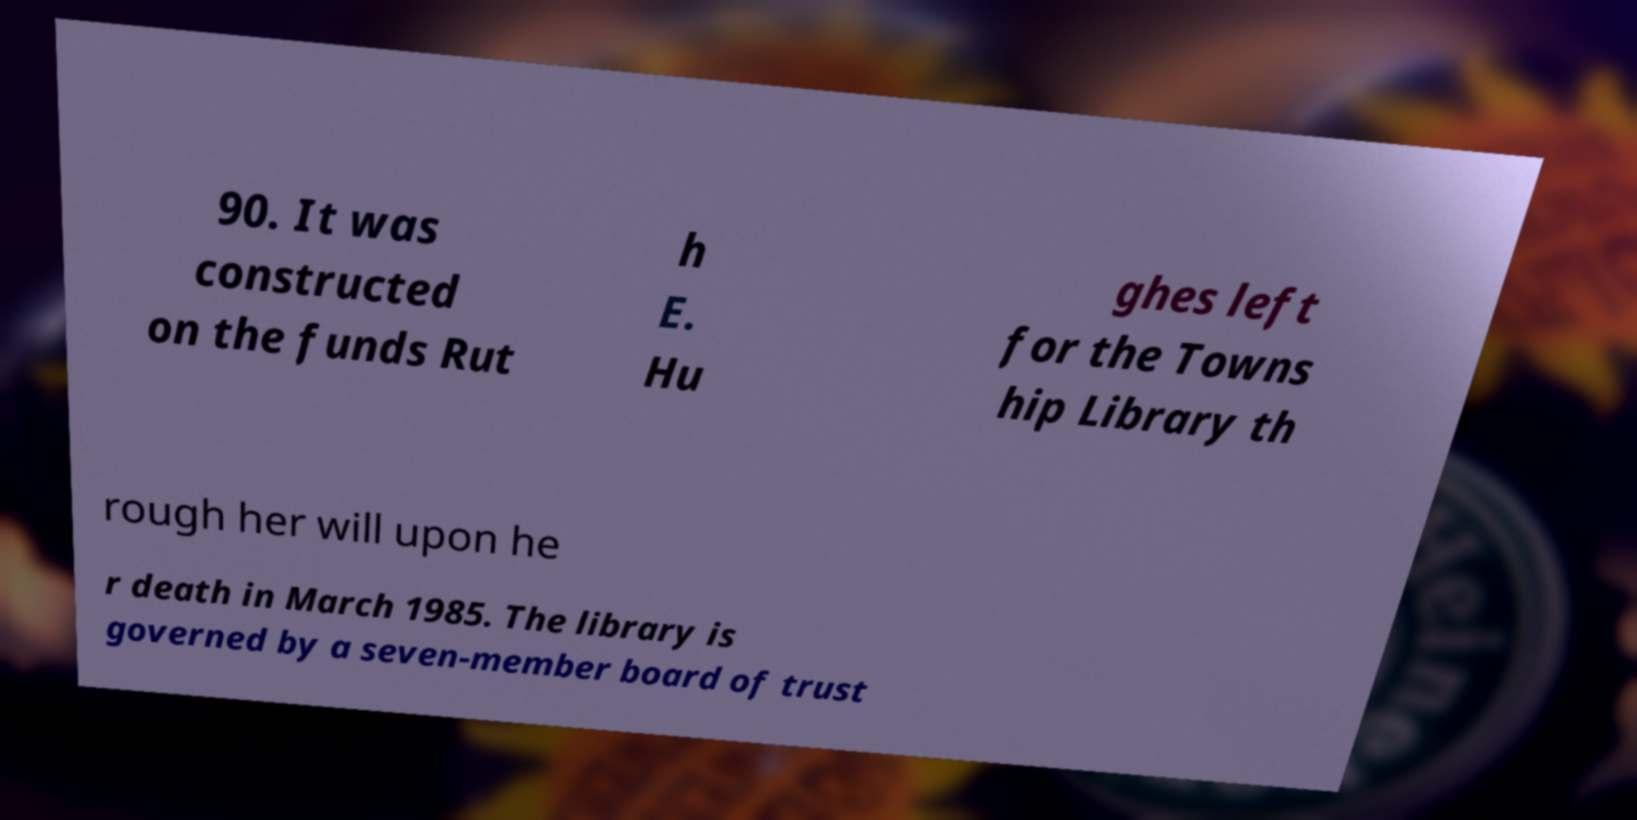What messages or text are displayed in this image? I need them in a readable, typed format. 90. It was constructed on the funds Rut h E. Hu ghes left for the Towns hip Library th rough her will upon he r death in March 1985. The library is governed by a seven-member board of trust 